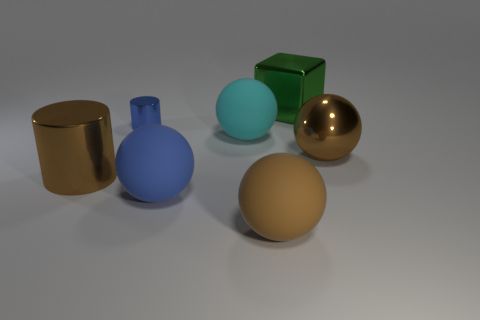Subtract all rubber spheres. How many spheres are left? 1 Subtract all green cylinders. How many brown spheres are left? 2 Add 3 large cyan objects. How many objects exist? 10 Subtract all brown spheres. How many spheres are left? 2 Subtract all balls. How many objects are left? 3 Subtract all blue metal cylinders. Subtract all small blue things. How many objects are left? 5 Add 1 large metal cylinders. How many large metal cylinders are left? 2 Add 4 tiny metal cylinders. How many tiny metal cylinders exist? 5 Subtract 0 gray cubes. How many objects are left? 7 Subtract 2 spheres. How many spheres are left? 2 